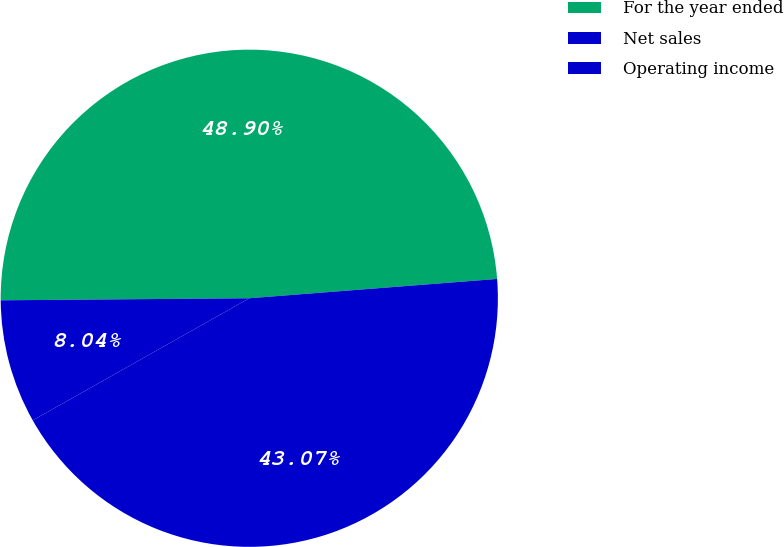Convert chart to OTSL. <chart><loc_0><loc_0><loc_500><loc_500><pie_chart><fcel>For the year ended<fcel>Net sales<fcel>Operating income<nl><fcel>48.9%<fcel>43.07%<fcel>8.04%<nl></chart> 